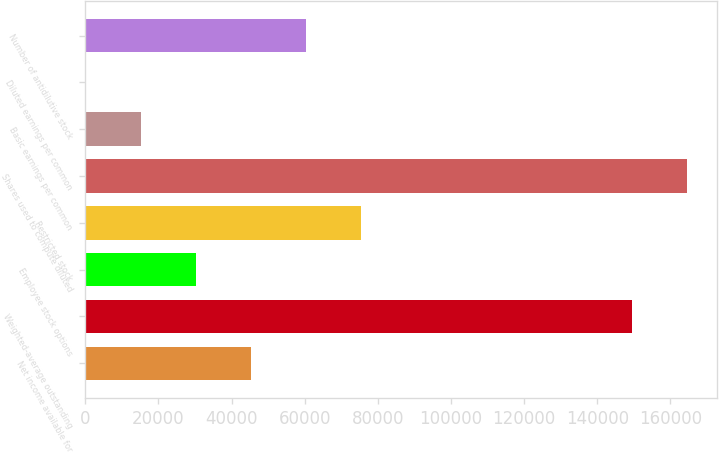<chart> <loc_0><loc_0><loc_500><loc_500><bar_chart><fcel>Net income available for<fcel>Weighted-average outstanding<fcel>Employee stock options<fcel>Restricted stock<fcel>Shares used to compute diluted<fcel>Basic earnings per common<fcel>Diluted earnings per common<fcel>Number of antidilutive stock<nl><fcel>45277.9<fcel>149375<fcel>30186.7<fcel>75460.5<fcel>164466<fcel>15095.4<fcel>4.07<fcel>60369.2<nl></chart> 